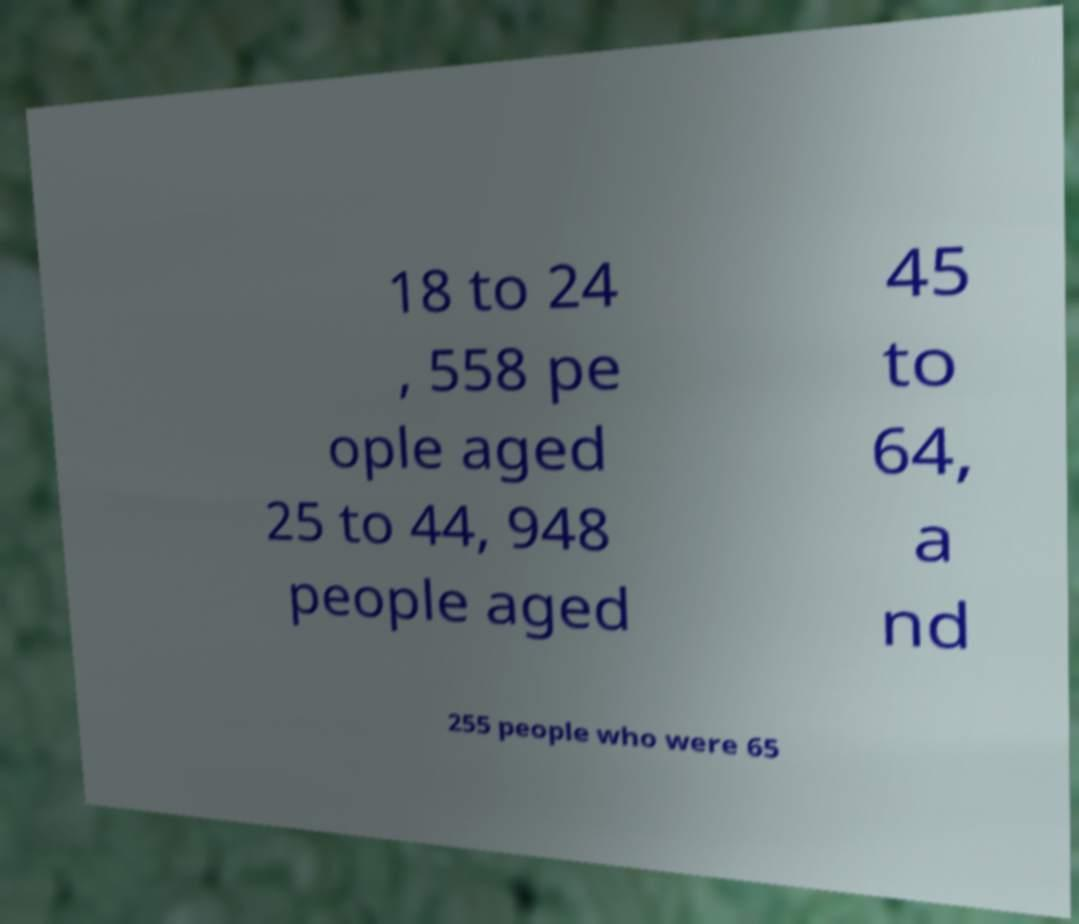Can you read and provide the text displayed in the image?This photo seems to have some interesting text. Can you extract and type it out for me? 18 to 24 , 558 pe ople aged 25 to 44, 948 people aged 45 to 64, a nd 255 people who were 65 